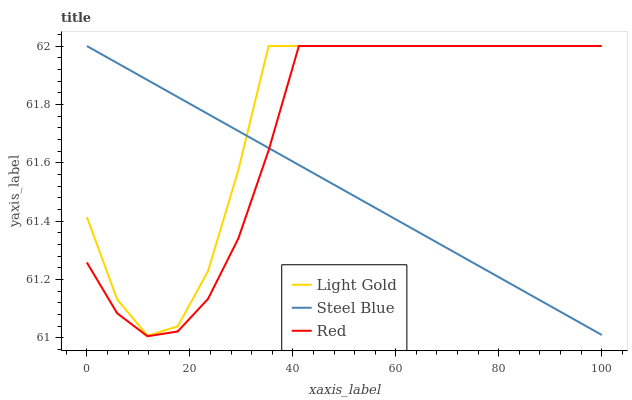Does Steel Blue have the minimum area under the curve?
Answer yes or no. Yes. Does Light Gold have the maximum area under the curve?
Answer yes or no. Yes. Does Red have the minimum area under the curve?
Answer yes or no. No. Does Red have the maximum area under the curve?
Answer yes or no. No. Is Steel Blue the smoothest?
Answer yes or no. Yes. Is Light Gold the roughest?
Answer yes or no. Yes. Is Red the smoothest?
Answer yes or no. No. Is Red the roughest?
Answer yes or no. No. Does Steel Blue have the lowest value?
Answer yes or no. No. Does Red have the highest value?
Answer yes or no. Yes. Does Steel Blue intersect Light Gold?
Answer yes or no. Yes. Is Steel Blue less than Light Gold?
Answer yes or no. No. Is Steel Blue greater than Light Gold?
Answer yes or no. No. 